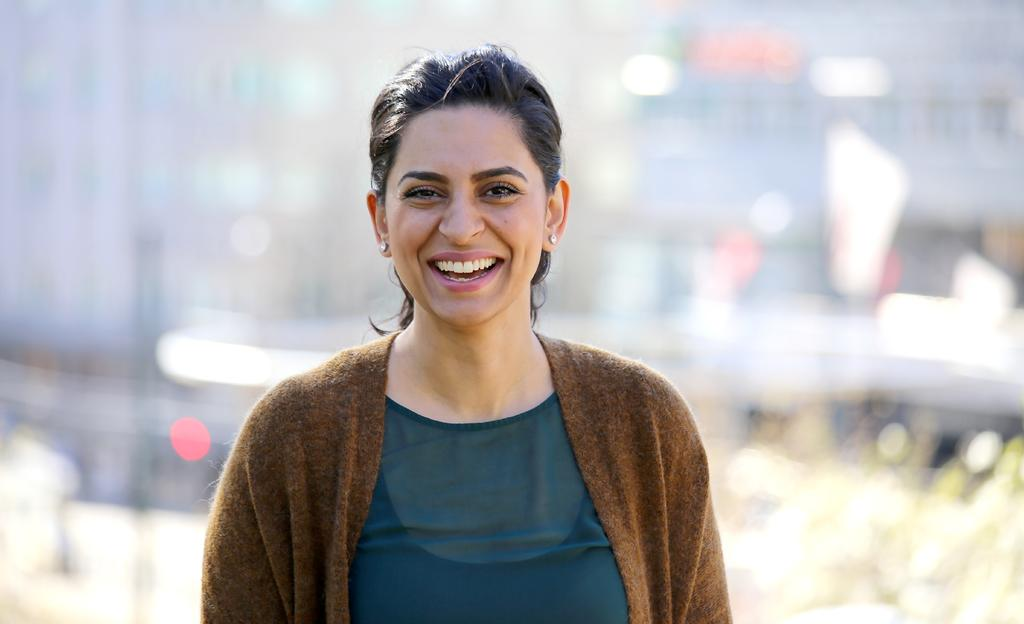What is the main subject of the image? There is a woman in the image. What is the woman doing in the image? The woman is standing. What is the woman wearing in the image? The woman is wearing a green dress and a brown dress on top of it. What is the woman's facial expression in the image? The woman is smiling. Can you describe the background of the image? The background of the image is not clear. What is the weight of the mist in the image? There is no mist present in the image, so it is not possible to determine its weight. 